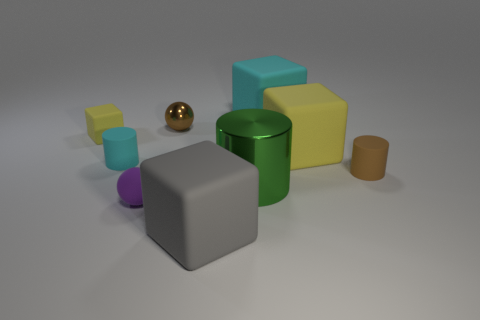What material is the small brown thing in front of the cylinder on the left side of the large green thing that is in front of the large yellow rubber object made of?
Give a very brief answer. Rubber. What material is the other thing that is the same color as the tiny shiny object?
Offer a terse response. Rubber. There is a tiny cylinder right of the gray thing; is its color the same as the large rubber thing on the right side of the cyan block?
Provide a succinct answer. No. There is a yellow rubber object to the left of the big cube in front of the small cylinder to the right of the big shiny cylinder; what is its shape?
Provide a succinct answer. Cube. What shape is the matte object that is to the left of the cyan block and behind the big yellow object?
Offer a very short reply. Cube. There is a big matte thing that is in front of the cylinder on the right side of the cyan rubber cube; what number of cylinders are on the left side of it?
Keep it short and to the point. 1. What is the size of the gray matte thing that is the same shape as the large cyan rubber thing?
Your response must be concise. Large. Does the yellow cube on the right side of the rubber sphere have the same material as the large cylinder?
Provide a short and direct response. No. There is another tiny thing that is the same shape as the purple thing; what is its color?
Provide a succinct answer. Brown. How many other things are there of the same color as the large cylinder?
Offer a very short reply. 0. 